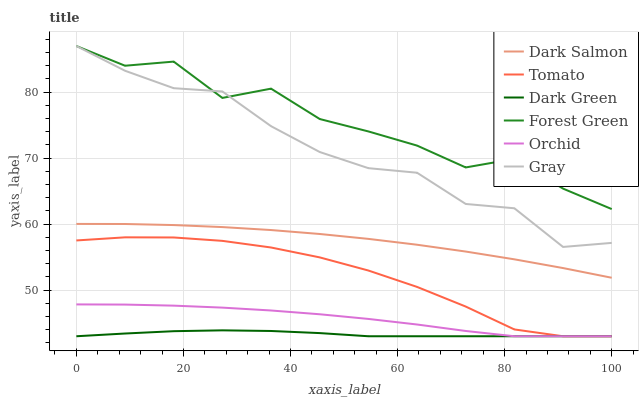Does Dark Green have the minimum area under the curve?
Answer yes or no. Yes. Does Forest Green have the maximum area under the curve?
Answer yes or no. Yes. Does Gray have the minimum area under the curve?
Answer yes or no. No. Does Gray have the maximum area under the curve?
Answer yes or no. No. Is Dark Green the smoothest?
Answer yes or no. Yes. Is Forest Green the roughest?
Answer yes or no. Yes. Is Gray the smoothest?
Answer yes or no. No. Is Gray the roughest?
Answer yes or no. No. Does Tomato have the lowest value?
Answer yes or no. Yes. Does Gray have the lowest value?
Answer yes or no. No. Does Forest Green have the highest value?
Answer yes or no. Yes. Does Dark Salmon have the highest value?
Answer yes or no. No. Is Orchid less than Forest Green?
Answer yes or no. Yes. Is Gray greater than Tomato?
Answer yes or no. Yes. Does Orchid intersect Tomato?
Answer yes or no. Yes. Is Orchid less than Tomato?
Answer yes or no. No. Is Orchid greater than Tomato?
Answer yes or no. No. Does Orchid intersect Forest Green?
Answer yes or no. No. 